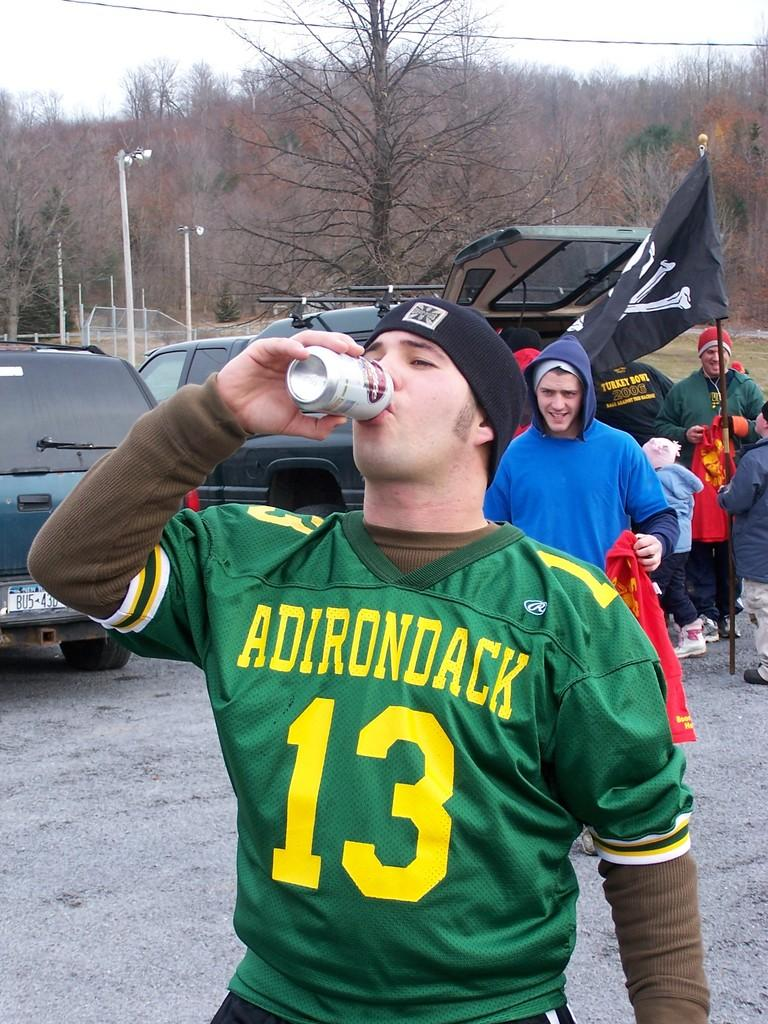Provide a one-sentence caption for the provided image. THE MAN IS WEARING A GREEN JERSEY WITH ADIRONDACK ON IT. 